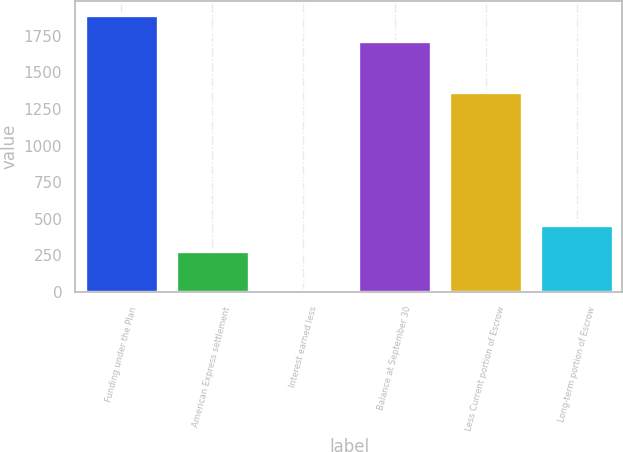Convert chart. <chart><loc_0><loc_0><loc_500><loc_500><bar_chart><fcel>Funding under the Plan<fcel>American Express settlement<fcel>Interest earned less<fcel>Balance at September 30<fcel>Less Current portion of Escrow<fcel>Long-term portion of Escrow<nl><fcel>1893.5<fcel>280<fcel>15<fcel>1715<fcel>1365<fcel>458.5<nl></chart> 